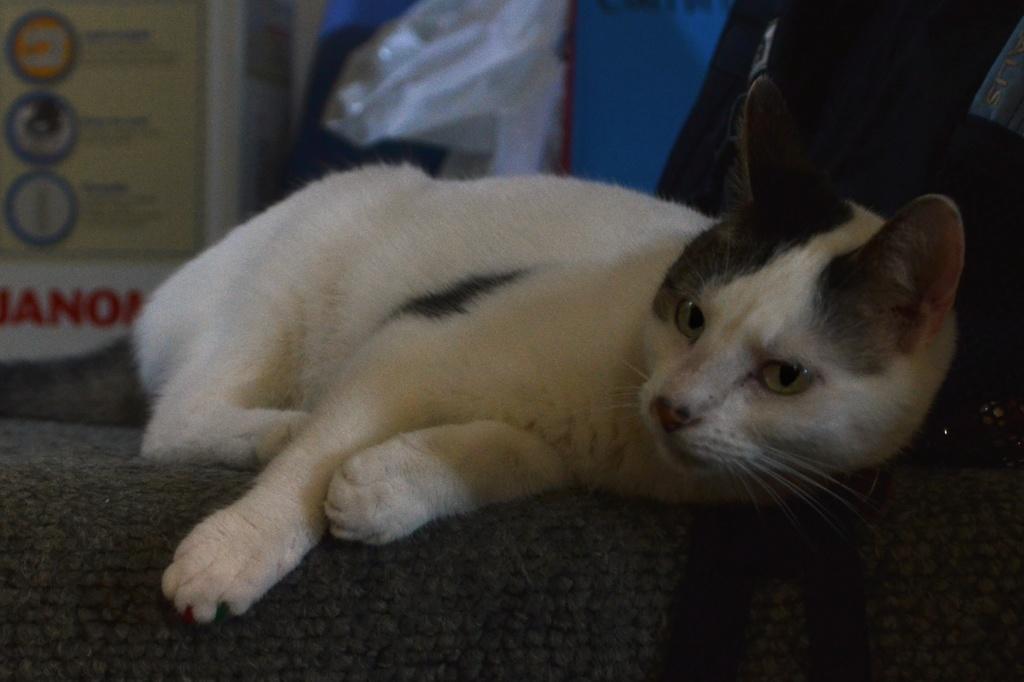Describe this image in one or two sentences. n this image, in the middle, we can see a cat lying on the mat. In the background, we can see a polythene cover and a chart. At the bottom, we can see a black color mat. 